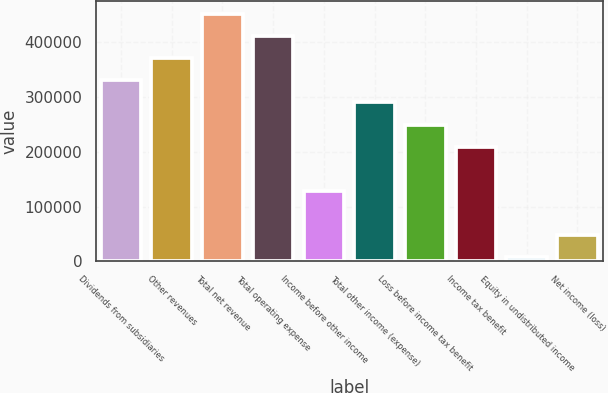Convert chart. <chart><loc_0><loc_0><loc_500><loc_500><bar_chart><fcel>Dividends from subsidiaries<fcel>Other revenues<fcel>Total net revenue<fcel>Total operating expense<fcel>Income before other income<fcel>Total other income (expense)<fcel>Loss before income tax benefit<fcel>Income tax benefit<fcel>Equity in undistributed income<fcel>Net income (loss)<nl><fcel>330888<fcel>371357<fcel>452295<fcel>411826<fcel>128544<fcel>290419<fcel>249950<fcel>209482<fcel>7137<fcel>47605.9<nl></chart> 